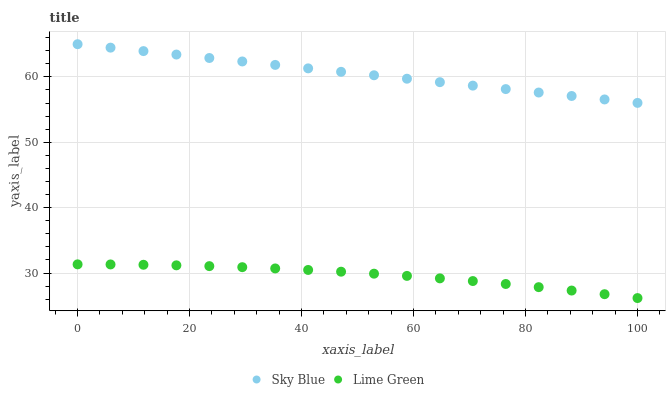Does Lime Green have the minimum area under the curve?
Answer yes or no. Yes. Does Sky Blue have the maximum area under the curve?
Answer yes or no. Yes. Does Lime Green have the maximum area under the curve?
Answer yes or no. No. Is Sky Blue the smoothest?
Answer yes or no. Yes. Is Lime Green the roughest?
Answer yes or no. Yes. Is Lime Green the smoothest?
Answer yes or no. No. Does Lime Green have the lowest value?
Answer yes or no. Yes. Does Sky Blue have the highest value?
Answer yes or no. Yes. Does Lime Green have the highest value?
Answer yes or no. No. Is Lime Green less than Sky Blue?
Answer yes or no. Yes. Is Sky Blue greater than Lime Green?
Answer yes or no. Yes. Does Lime Green intersect Sky Blue?
Answer yes or no. No. 